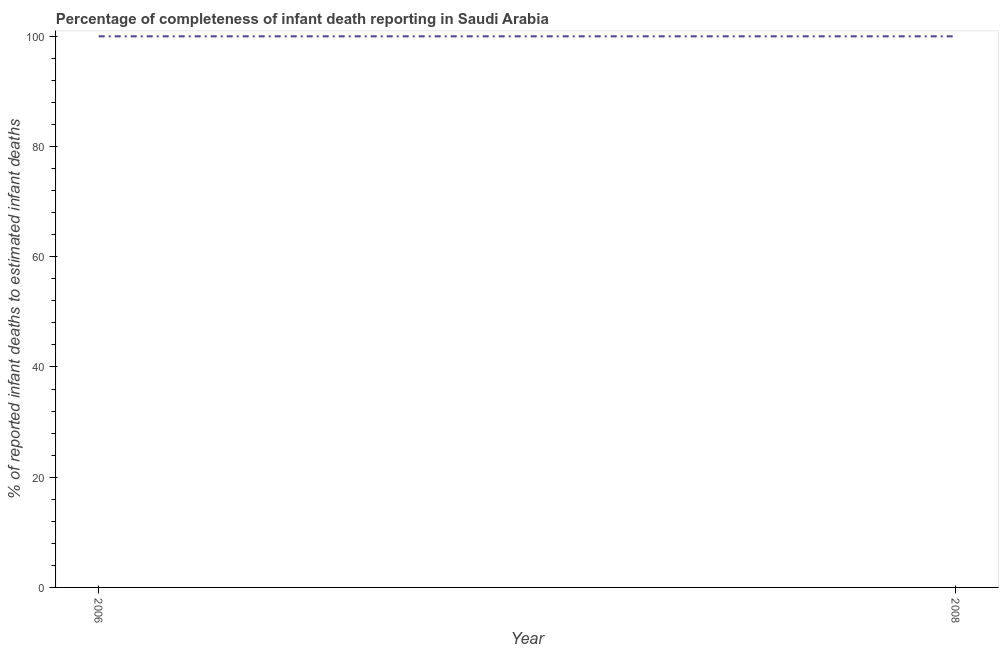What is the completeness of infant death reporting in 2006?
Your response must be concise. 100. Across all years, what is the maximum completeness of infant death reporting?
Provide a short and direct response. 100. Across all years, what is the minimum completeness of infant death reporting?
Offer a very short reply. 100. In which year was the completeness of infant death reporting maximum?
Make the answer very short. 2006. In which year was the completeness of infant death reporting minimum?
Make the answer very short. 2006. What is the sum of the completeness of infant death reporting?
Provide a succinct answer. 200. What is the median completeness of infant death reporting?
Provide a succinct answer. 100. What is the ratio of the completeness of infant death reporting in 2006 to that in 2008?
Provide a succinct answer. 1. Does the completeness of infant death reporting monotonically increase over the years?
Provide a succinct answer. No. How many lines are there?
Your answer should be very brief. 1. Are the values on the major ticks of Y-axis written in scientific E-notation?
Offer a very short reply. No. Does the graph contain any zero values?
Offer a terse response. No. Does the graph contain grids?
Keep it short and to the point. No. What is the title of the graph?
Ensure brevity in your answer.  Percentage of completeness of infant death reporting in Saudi Arabia. What is the label or title of the X-axis?
Offer a terse response. Year. What is the label or title of the Y-axis?
Offer a very short reply. % of reported infant deaths to estimated infant deaths. What is the % of reported infant deaths to estimated infant deaths in 2006?
Make the answer very short. 100. What is the % of reported infant deaths to estimated infant deaths of 2008?
Offer a very short reply. 100. What is the difference between the % of reported infant deaths to estimated infant deaths in 2006 and 2008?
Provide a short and direct response. 0. 